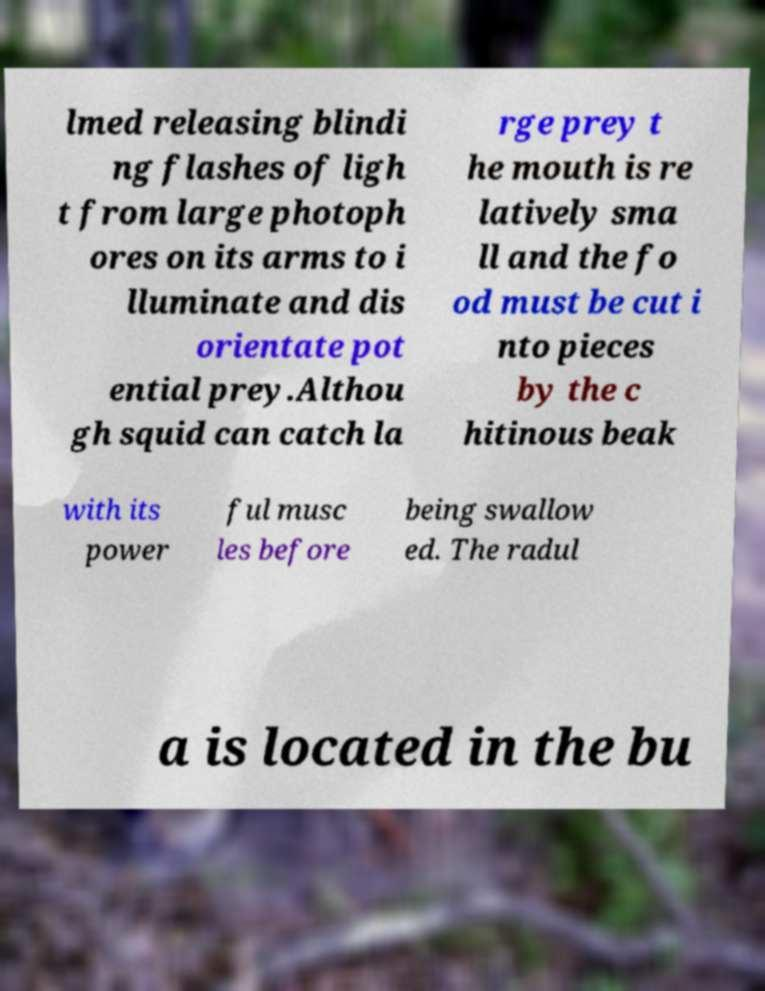Can you read and provide the text displayed in the image?This photo seems to have some interesting text. Can you extract and type it out for me? lmed releasing blindi ng flashes of ligh t from large photoph ores on its arms to i lluminate and dis orientate pot ential prey.Althou gh squid can catch la rge prey t he mouth is re latively sma ll and the fo od must be cut i nto pieces by the c hitinous beak with its power ful musc les before being swallow ed. The radul a is located in the bu 